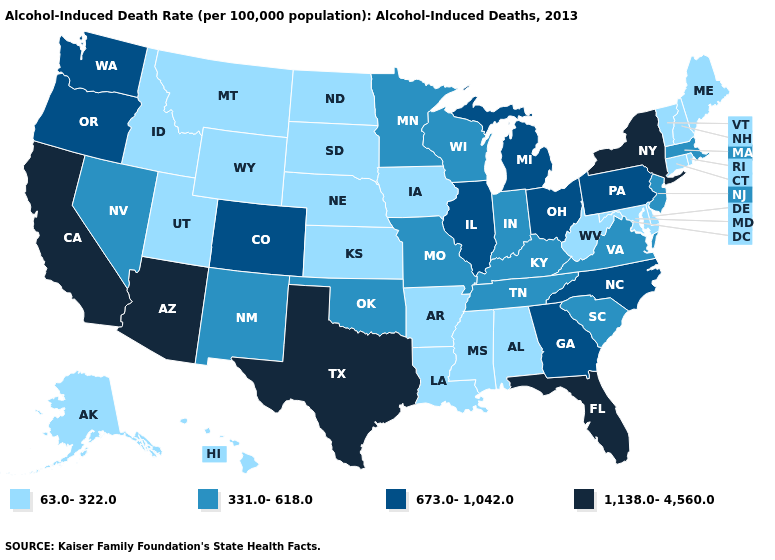How many symbols are there in the legend?
Keep it brief. 4. What is the value of Louisiana?
Write a very short answer. 63.0-322.0. What is the value of Maine?
Write a very short answer. 63.0-322.0. Among the states that border Kansas , which have the lowest value?
Concise answer only. Nebraska. What is the value of New Mexico?
Give a very brief answer. 331.0-618.0. How many symbols are there in the legend?
Give a very brief answer. 4. How many symbols are there in the legend?
Answer briefly. 4. What is the highest value in the USA?
Short answer required. 1,138.0-4,560.0. What is the value of Hawaii?
Short answer required. 63.0-322.0. What is the value of Indiana?
Keep it brief. 331.0-618.0. Does Iowa have a lower value than Montana?
Give a very brief answer. No. Does the map have missing data?
Concise answer only. No. What is the value of New Hampshire?
Keep it brief. 63.0-322.0. Which states hav the highest value in the South?
Answer briefly. Florida, Texas. Does Vermont have the lowest value in the Northeast?
Concise answer only. Yes. 